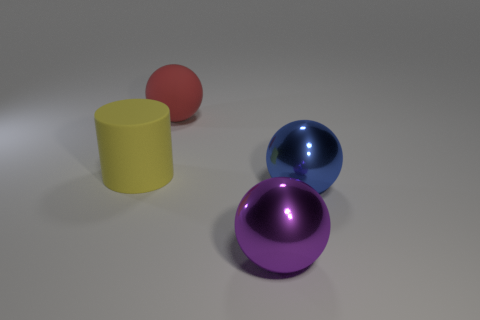Add 4 big red rubber balls. How many objects exist? 8 Subtract all cylinders. How many objects are left? 3 Subtract 1 purple spheres. How many objects are left? 3 Subtract all purple rubber blocks. Subtract all blue shiny things. How many objects are left? 3 Add 1 red rubber spheres. How many red rubber spheres are left? 2 Add 4 balls. How many balls exist? 7 